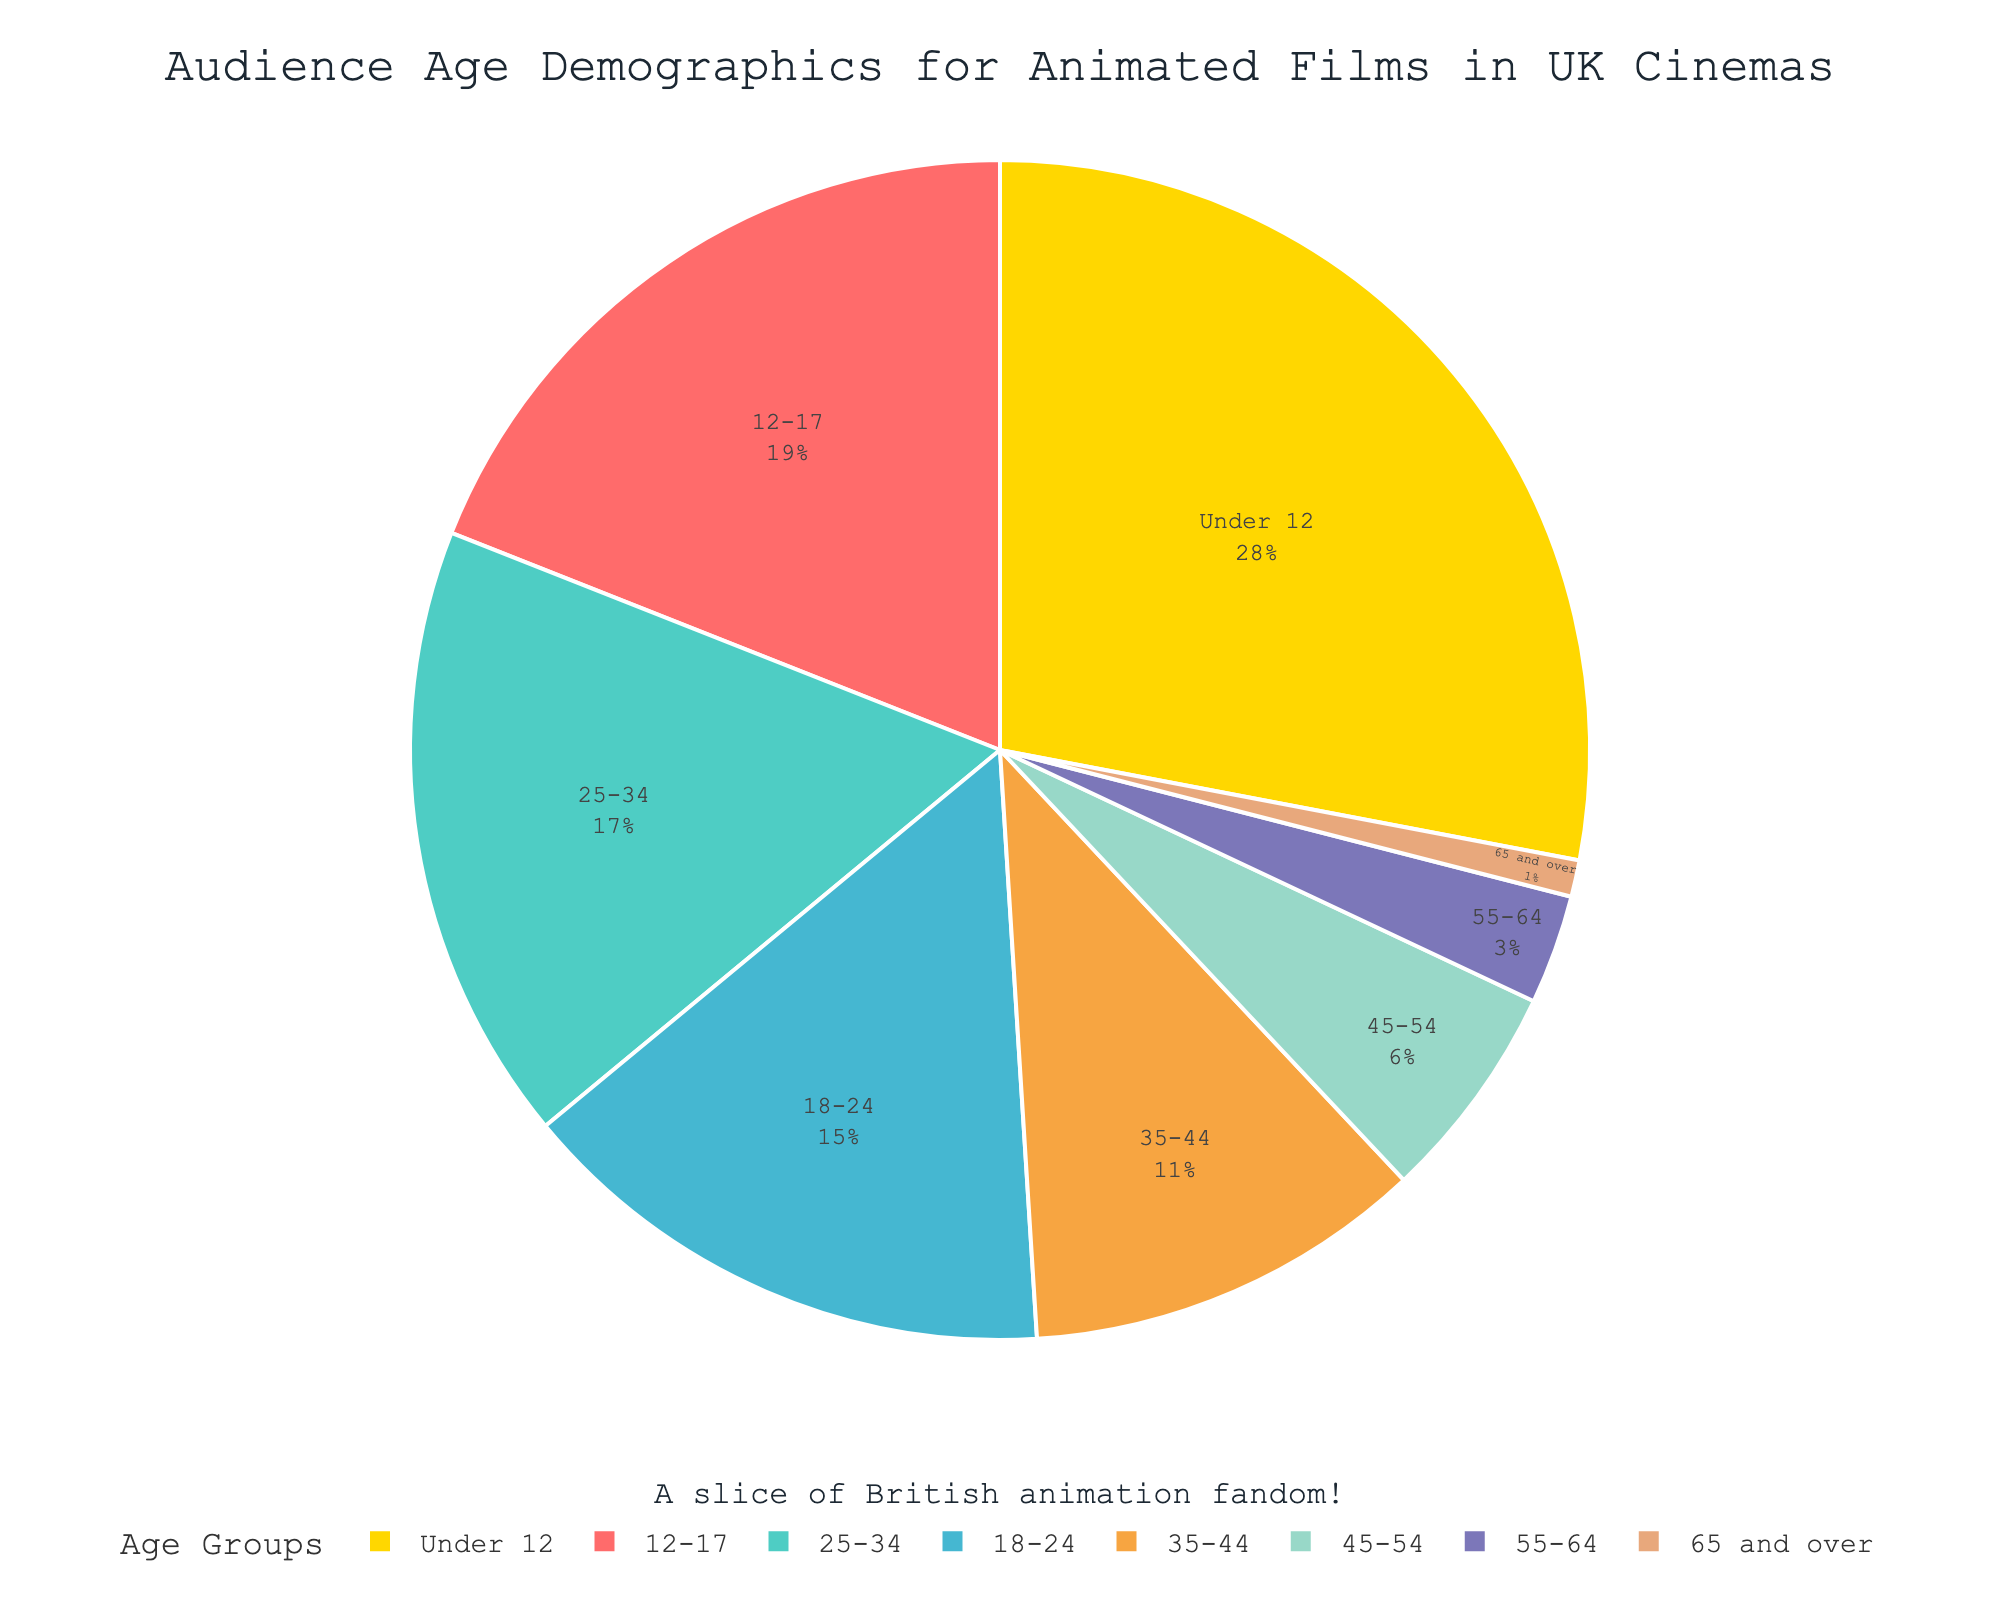What age group has the largest audience percentage for animated films in UK cinemas? According to the pie chart, the age group with the largest slice represents the greatest audience percentage. In this case, "Under 12" has the largest slice.
Answer: Under 12 Which two age groups combined have an audience percentage greater than 40%? Summing up the audience percentages of the groups is required. "Under 12" with 28% and "12-17" with 19% together sum to 47%, which is greater than 40%.
Answer: Under 12 and 12-17 Which age group represents the smallest audience percentage? Examine the smallest slice in the pie chart. The smallest slice corresponds to the "65 and over" age group with 1%.
Answer: 65 and over How does the audience percentage of the 18-24 age group compare with the 45-54 age group? Compare the percentages shown in the pie chart. 18-24 is 15% and 45-54 is 6%, revealing that 18-24 has a higher percentage.
Answer: 18-24 has a higher percentage If you combine the audience percentages of the 35-44 age group and the 45-54 age group, do they make up more or less than the audience percentage of the Under 12 age group? Add the percentages for 35-44 (11%) and 45-54 (6%) which total 17%, and compare this with the percentage for "Under 12" (28%). The combined percentage of 35-44 and 45-54 is less than "Under 12".
Answer: Less Which age group has a percentage closest to 20%? Identify the slice closest to 20%. The 12-17 age group with 19% is closest to 20%.
Answer: 12-17 What is the combined audience percentage of the age groups below 18? Sum the percentages of "Under 12" (28%) and "12-17" (19%). The total is 28% + 19% = 47%.
Answer: 47% What fraction does the 25-34 age group represent compared to the total audience? The 25-34 age group represents 17% of the total. As a fraction, it is 17%.
Answer: 17% Which age group has a greater audience percentage: 18-24 or 25-34? Compare the percentages of the 18-24 (15%) and 25-34 (17%) age groups. The 25-34 age group has a greater percentage.
Answer: 25-34 Does the percentage of the 55-64 group exceed the combined percentage of the 65 and over and 45-54 groups? Compare the sum of the 65 and over (1%) and 45-54 (6%) with the 55-64 (3%). The sum is 1% + 6% = 7%, which exceeds 3%.
Answer: No 